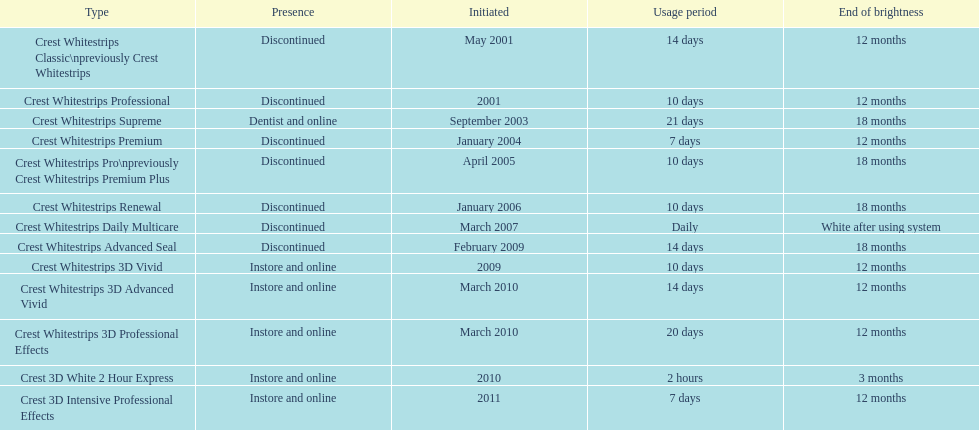What's the total count of discontinued products? 7. 